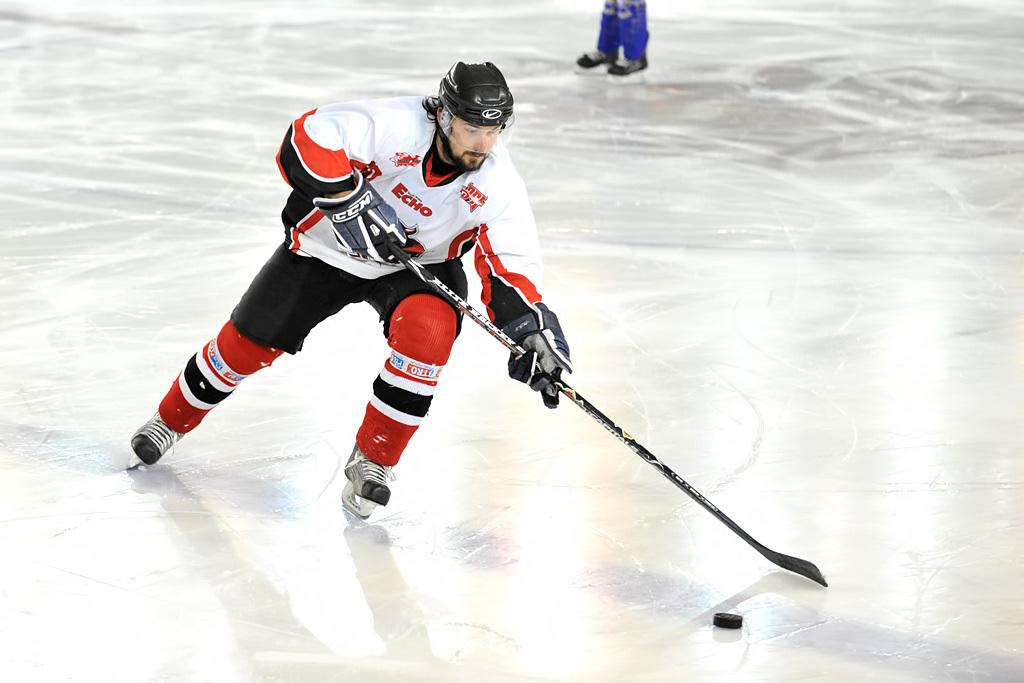What sport is the person in the image participating in? The person in the image is playing ice hockey. Can you describe the surface on which the sport is being played? The surface in the image is ice. Are there any other people visible in the image besides the person playing ice hockey? Yes, the legs of other persons are visible in the image. What type of star can be seen in the image? There is no star visible in the image; it is focused on a person playing ice hockey on an icy surface. 